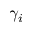Convert formula to latex. <formula><loc_0><loc_0><loc_500><loc_500>\gamma _ { i }</formula> 